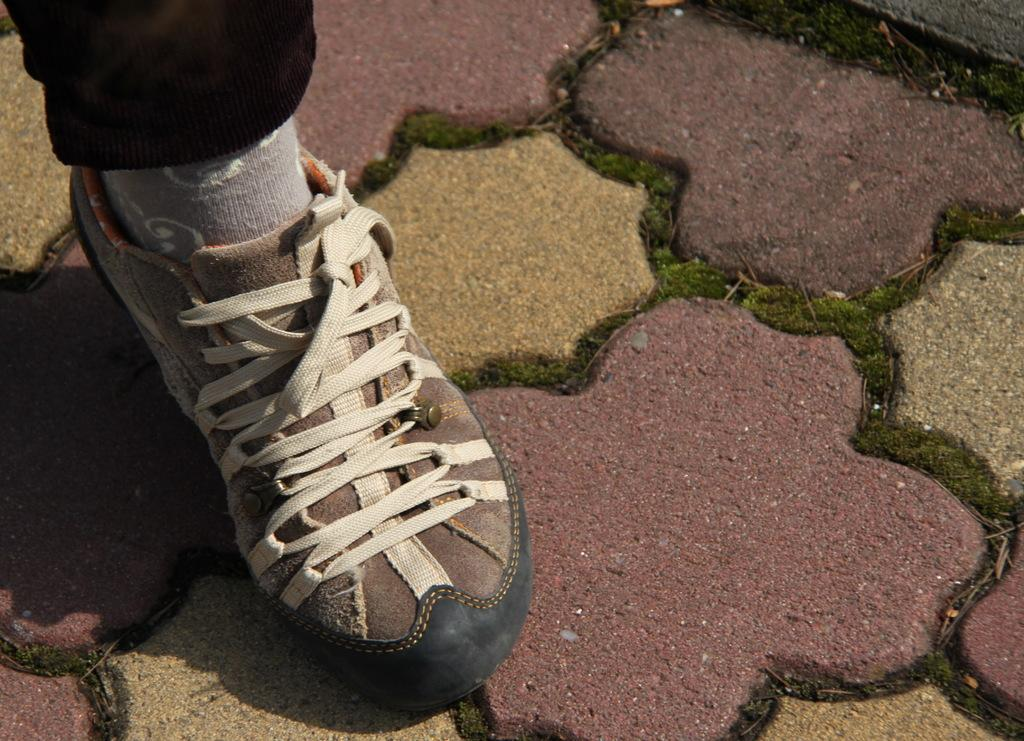What part of a person's body is visible in the image? There is a person's leg visible in the image. What is the leg wearing on its feet? The leg is wearing socks and shoes. Where is the leg positioned in the image? The leg is on the ground. Is the person wearing a hat while riding a bike in the wilderness in the image? There is no bike, hat, or wilderness present in the image; it only shows a person's leg wearing socks and shoes on the ground. 